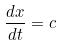Convert formula to latex. <formula><loc_0><loc_0><loc_500><loc_500>\frac { d x } { d t } = c</formula> 